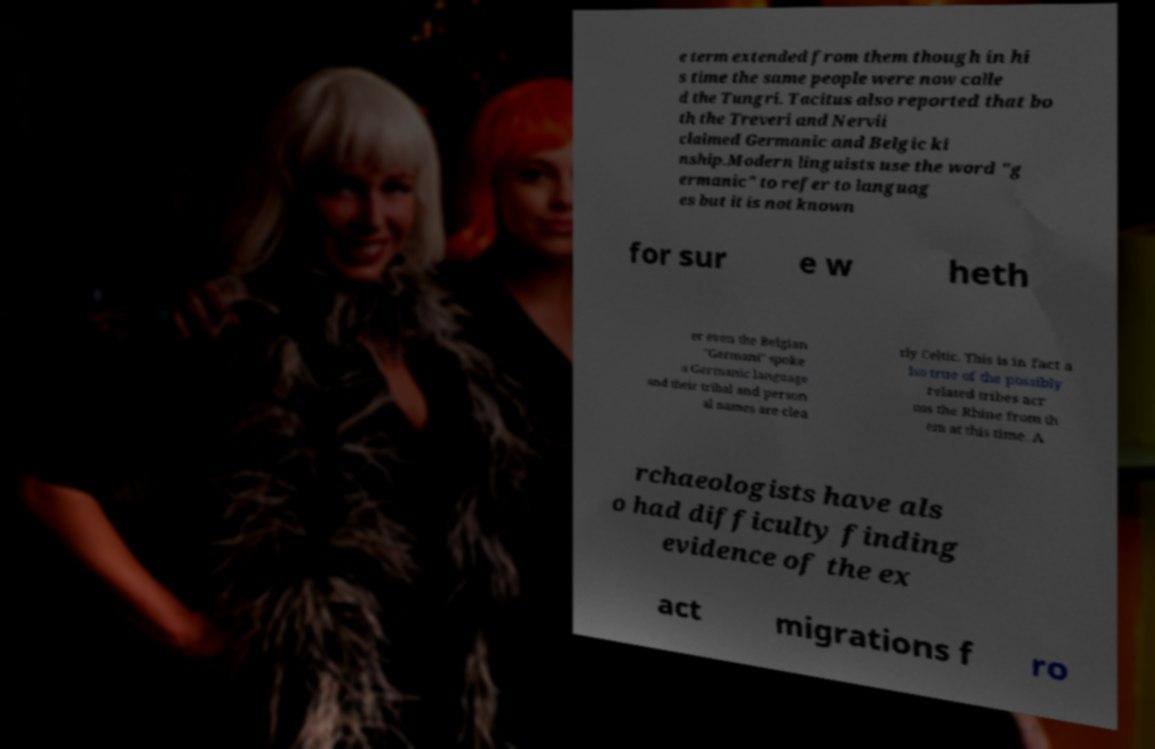There's text embedded in this image that I need extracted. Can you transcribe it verbatim? e term extended from them though in hi s time the same people were now calle d the Tungri. Tacitus also reported that bo th the Treveri and Nervii claimed Germanic and Belgic ki nship.Modern linguists use the word "g ermanic" to refer to languag es but it is not known for sur e w heth er even the Belgian "Germani" spoke a Germanic language and their tribal and person al names are clea rly Celtic. This is in fact a lso true of the possibly related tribes acr oss the Rhine from th em at this time. A rchaeologists have als o had difficulty finding evidence of the ex act migrations f ro 